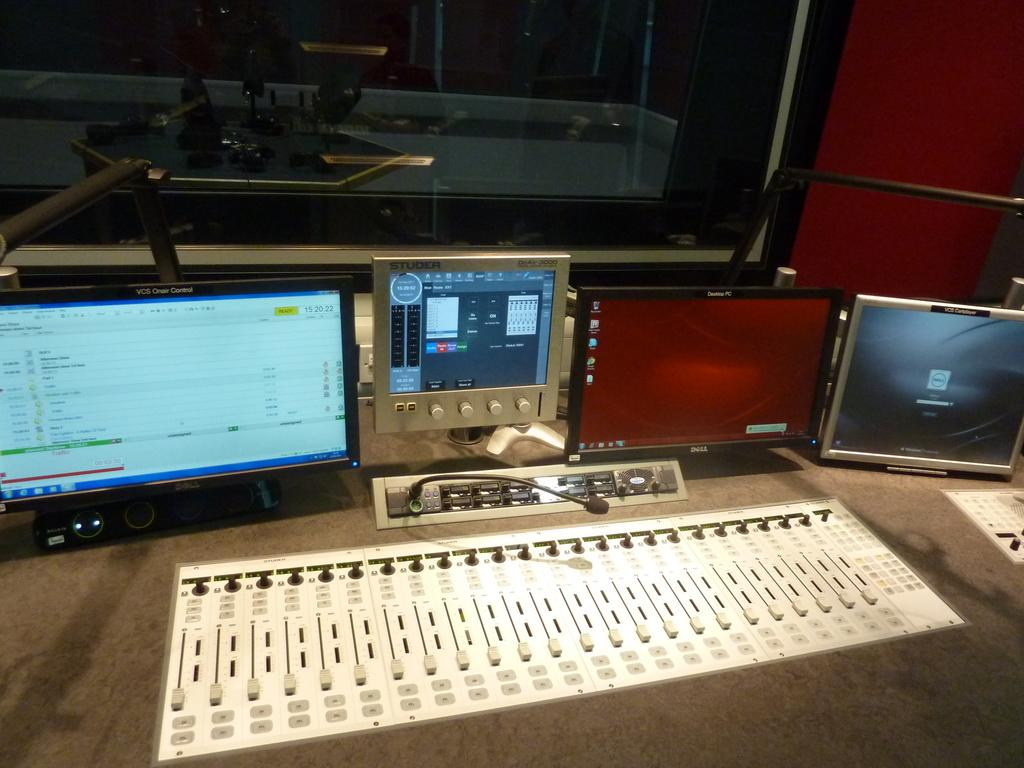Provide a one-sentence caption for the provided image. A sound studio board and a Studer instrument panel. 